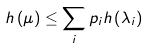Convert formula to latex. <formula><loc_0><loc_0><loc_500><loc_500>h \left ( \mu \right ) \leq \sum _ { i } p _ { i } h \left ( \lambda _ { i } \right )</formula> 